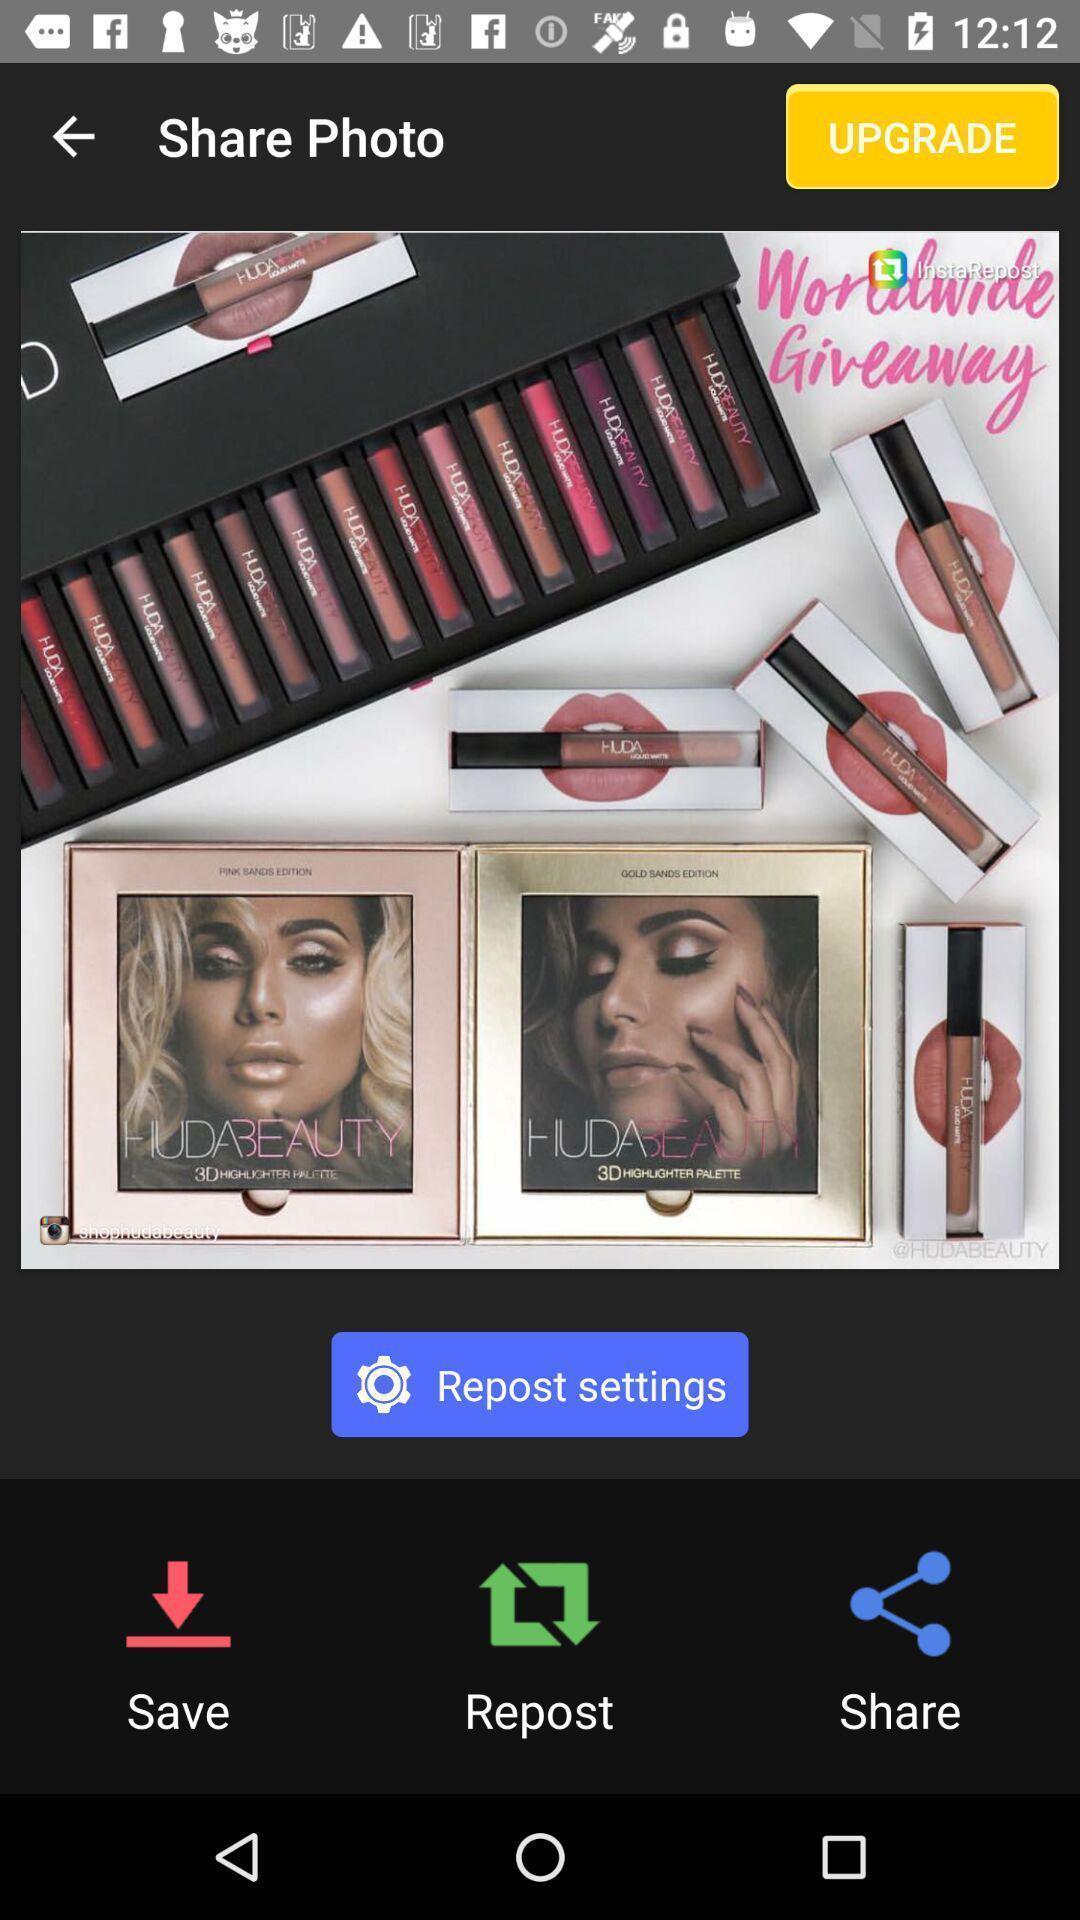Give me a summary of this screen capture. Screen displaying the photo to share. 